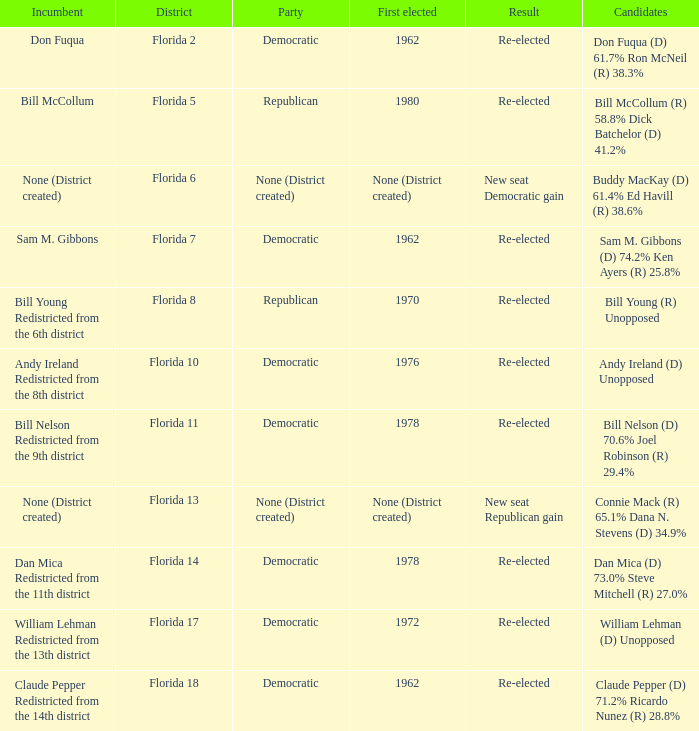What's the first elected with district being florida 7 1962.0. 